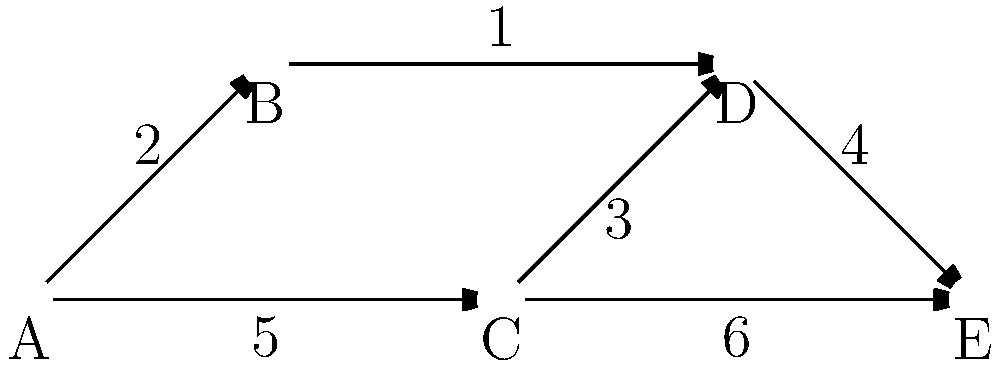In this network diagram representing a sudoku puzzle-solving algorithm, each node represents a state of the puzzle, and the edges represent possible moves with their associated costs. What is the shortest path from node A to node E, and what is its total cost? To find the shortest path from node A to node E, we need to consider all possible paths and their total costs. Let's break it down step by step:

1. Possible paths from A to E:
   a) A → B → D → E
   b) A → C → D → E
   c) A → C → E

2. Calculate the cost of each path:
   a) A → B → D → E: 2 + 1 + 4 = 7
   b) A → C → D → E: 5 + 3 + 4 = 12
   c) A → C → E: 5 + 6 = 11

3. Compare the costs:
   Path (a) has the lowest cost of 7, making it the shortest path.

4. Shortest path: A → B → D → E
   Total cost: 7

Therefore, the shortest path from node A to node E is A → B → D → E, with a total cost of 7.
Answer: A → B → D → E, cost = 7 